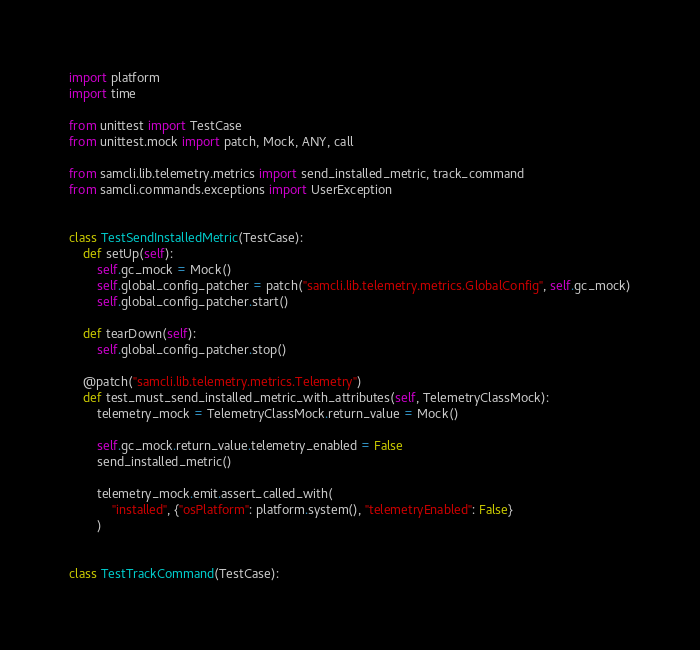<code> <loc_0><loc_0><loc_500><loc_500><_Python_>import platform
import time

from unittest import TestCase
from unittest.mock import patch, Mock, ANY, call

from samcli.lib.telemetry.metrics import send_installed_metric, track_command
from samcli.commands.exceptions import UserException


class TestSendInstalledMetric(TestCase):
    def setUp(self):
        self.gc_mock = Mock()
        self.global_config_patcher = patch("samcli.lib.telemetry.metrics.GlobalConfig", self.gc_mock)
        self.global_config_patcher.start()

    def tearDown(self):
        self.global_config_patcher.stop()

    @patch("samcli.lib.telemetry.metrics.Telemetry")
    def test_must_send_installed_metric_with_attributes(self, TelemetryClassMock):
        telemetry_mock = TelemetryClassMock.return_value = Mock()

        self.gc_mock.return_value.telemetry_enabled = False
        send_installed_metric()

        telemetry_mock.emit.assert_called_with(
            "installed", {"osPlatform": platform.system(), "telemetryEnabled": False}
        )


class TestTrackCommand(TestCase):</code> 